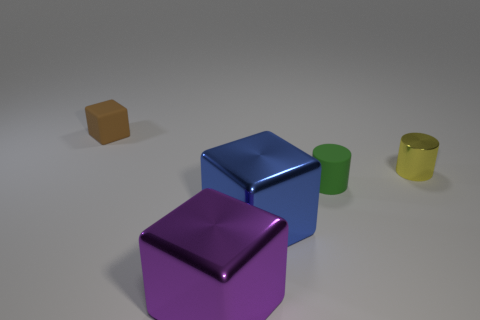Subtract all tiny cubes. How many cubes are left? 2 Subtract all cylinders. How many objects are left? 3 Add 1 blue matte blocks. How many objects exist? 6 Subtract all green cylinders. How many cylinders are left? 1 Subtract all yellow cylinders. Subtract all cyan cubes. How many cylinders are left? 1 Subtract all big red shiny spheres. Subtract all tiny brown blocks. How many objects are left? 4 Add 3 tiny brown rubber cubes. How many tiny brown rubber cubes are left? 4 Add 3 brown cubes. How many brown cubes exist? 4 Subtract 0 gray cylinders. How many objects are left? 5 Subtract 2 cylinders. How many cylinders are left? 0 